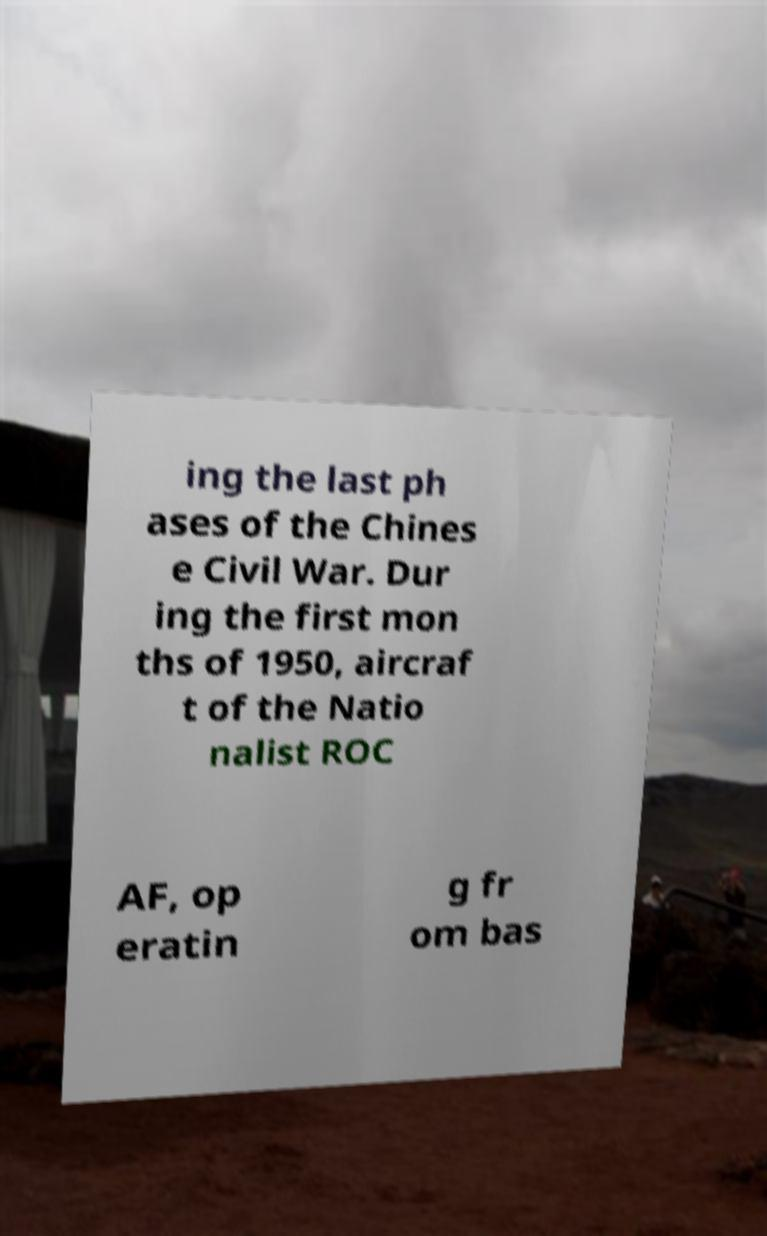What messages or text are displayed in this image? I need them in a readable, typed format. ing the last ph ases of the Chines e Civil War. Dur ing the first mon ths of 1950, aircraf t of the Natio nalist ROC AF, op eratin g fr om bas 